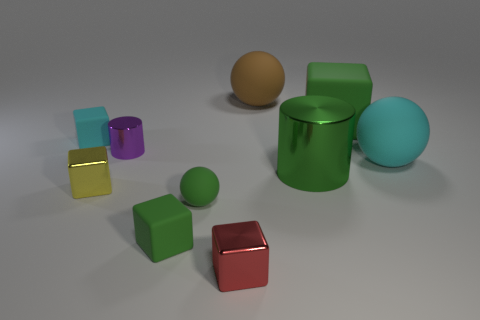What number of objects are either large green things that are in front of the tiny purple cylinder or green things that are left of the brown object?
Ensure brevity in your answer.  3. There is a rubber block right of the small red thing; is it the same color as the large object on the left side of the green metal thing?
Ensure brevity in your answer.  No. What is the shape of the shiny object that is both behind the red object and on the right side of the small purple object?
Ensure brevity in your answer.  Cylinder. What color is the other metallic block that is the same size as the yellow cube?
Your answer should be very brief. Red. Are there any objects of the same color as the tiny ball?
Your response must be concise. Yes. There is a rubber cube in front of the green rubber sphere; is it the same size as the cyan matte object right of the tiny yellow metallic object?
Your response must be concise. No. The cube that is both to the right of the cyan cube and behind the yellow thing is made of what material?
Your answer should be very brief. Rubber. There is a matte ball that is the same color as the big metallic cylinder; what size is it?
Provide a succinct answer. Small. How many other things are there of the same size as the cyan cube?
Provide a short and direct response. 5. There is a cylinder in front of the purple object; what material is it?
Your answer should be compact. Metal. 